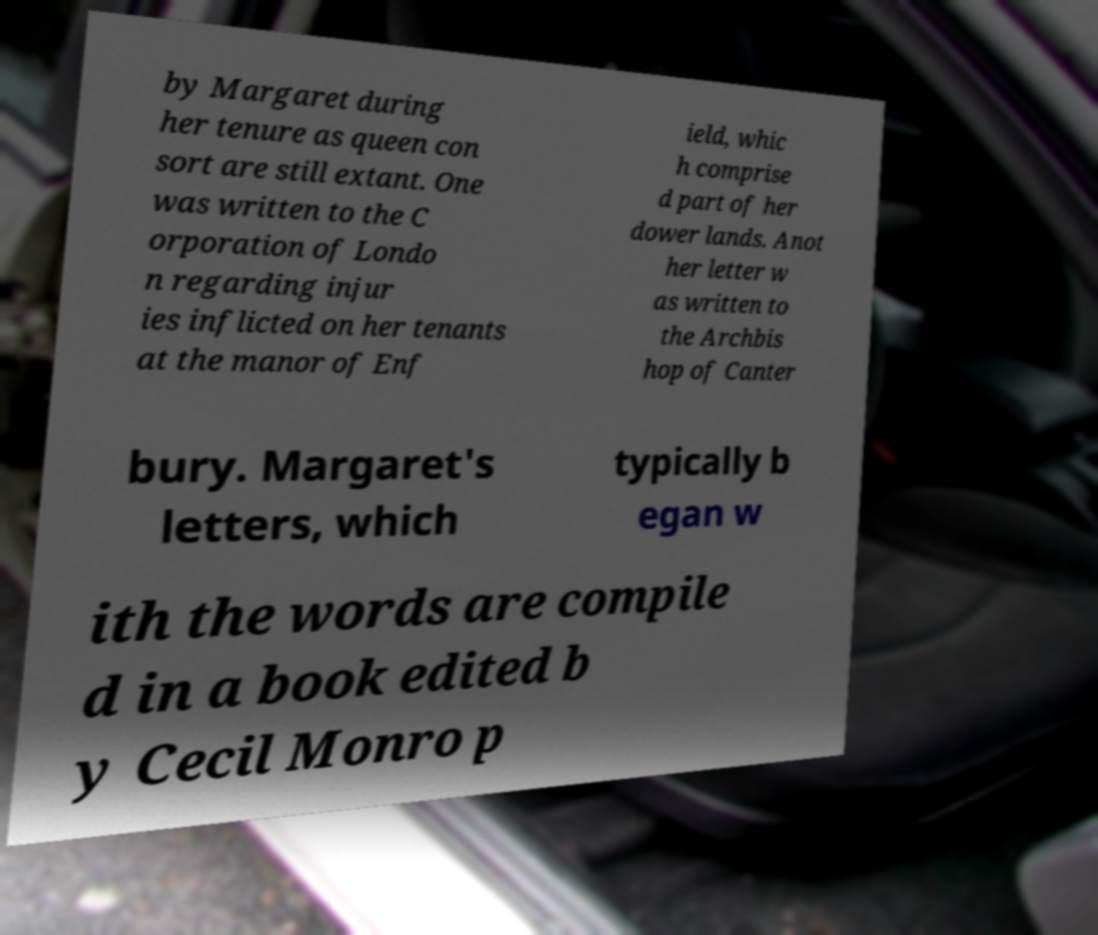What messages or text are displayed in this image? I need them in a readable, typed format. by Margaret during her tenure as queen con sort are still extant. One was written to the C orporation of Londo n regarding injur ies inflicted on her tenants at the manor of Enf ield, whic h comprise d part of her dower lands. Anot her letter w as written to the Archbis hop of Canter bury. Margaret's letters, which typically b egan w ith the words are compile d in a book edited b y Cecil Monro p 